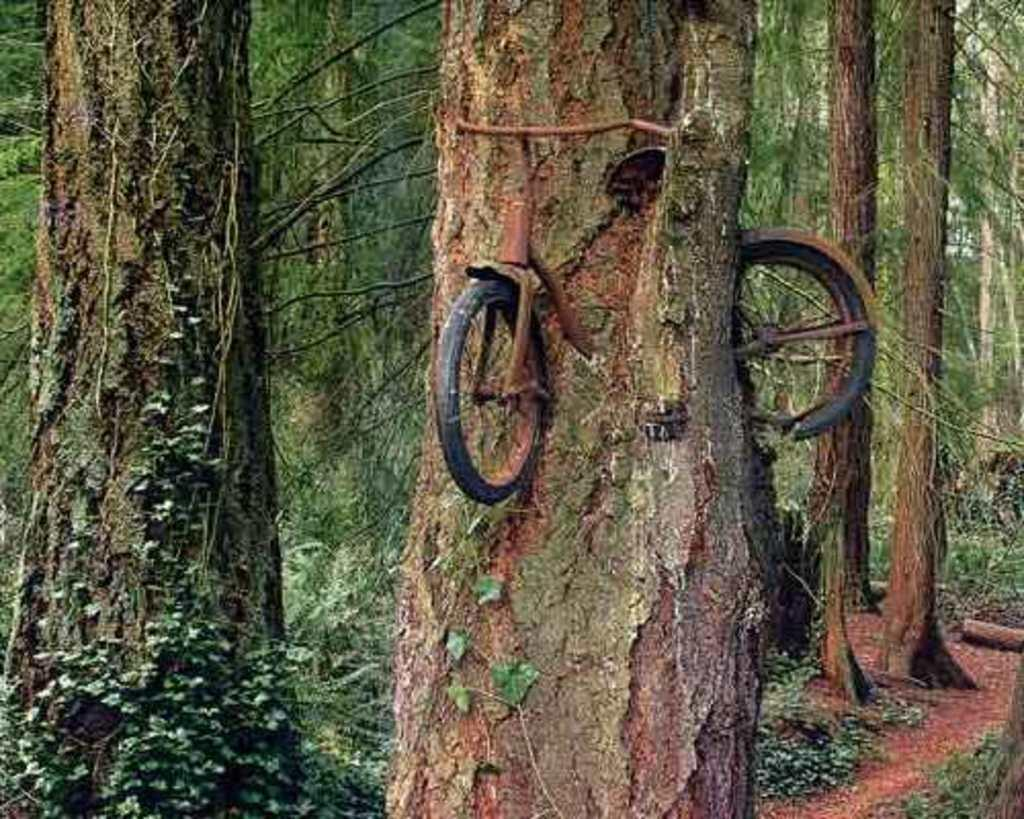What is the main object in the image? There is a bicycle in the image. What is the unusual situation with the bicycle? The bicycle is stuck in a tree trunk. What can be seen in the background of the image? There are trees in the background of the image. What type of metal is the clock made of in the image? There is no clock present in the image, so it is not possible to determine what type of metal it might be made of. 